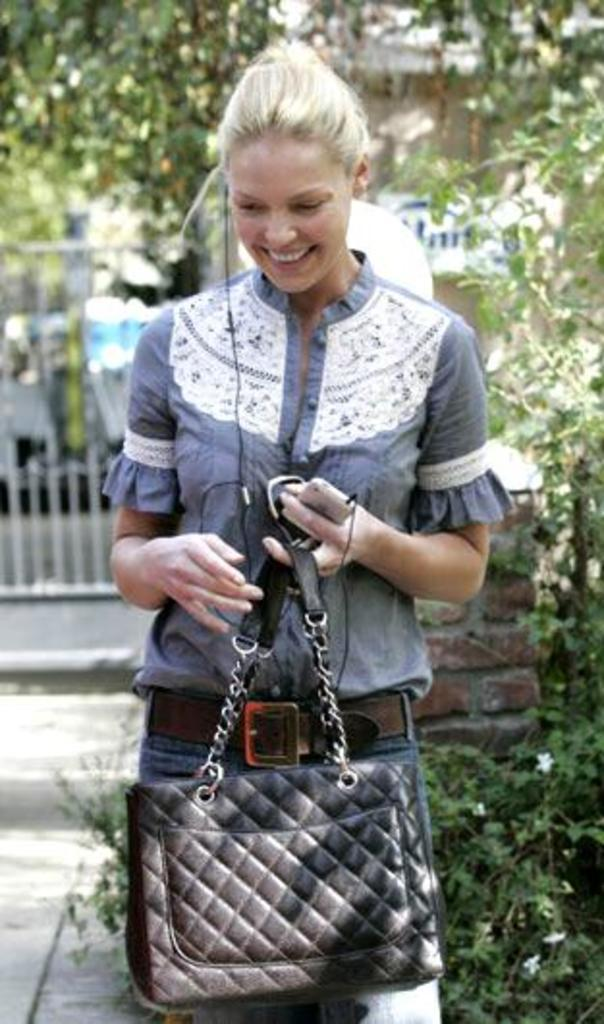What is the person in the image doing? The person is standing in the image. What is the person holding in their hands? The person is holding a bag and a mobile. What can be seen in the background of the image? There is a tree and a fence in the background of the image. What type of star is visible in the image? There is no star visible in the image. 